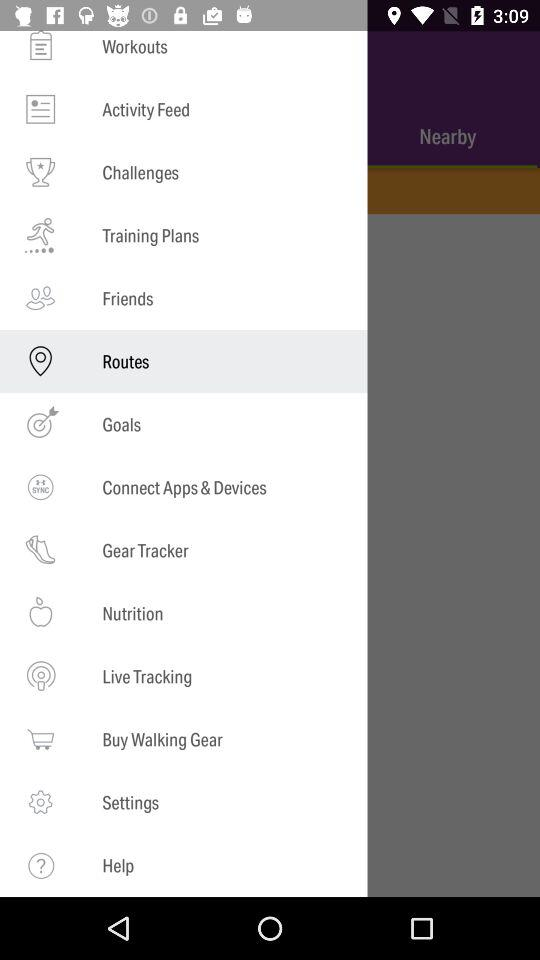Which option has been selected? The selected option is "Routes". 